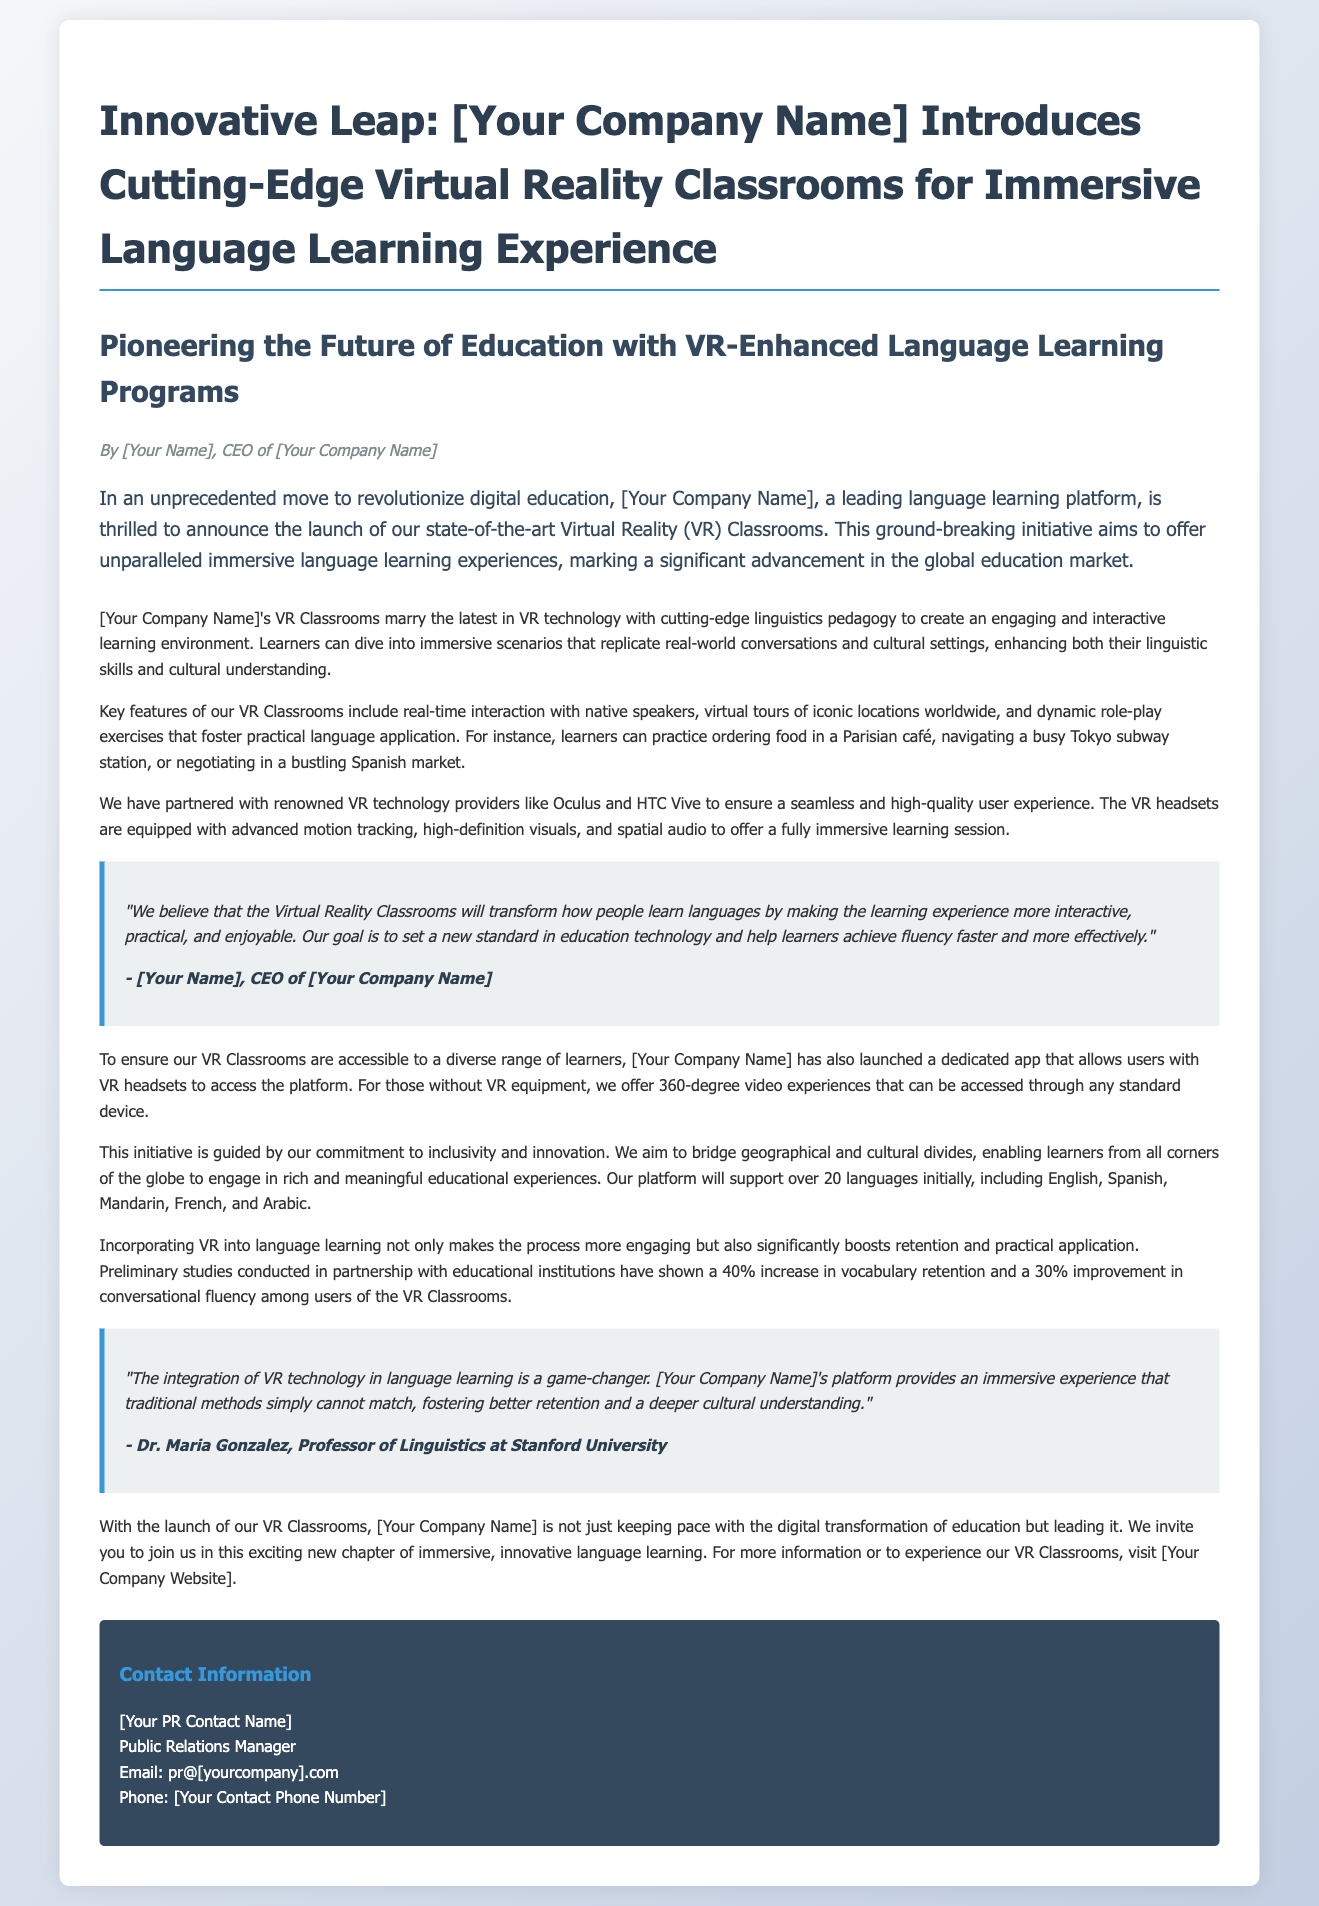What is the name of the company introducing VR Classrooms? The document states that the company is referred to as [Your Company Name], which indicates the placeholder for the actual company name.
Answer: [Your Company Name] What technology partners are mentioned for VR Classrooms? The document specifies that the company has partnered with Oculus and HTC Vive for the VR Classrooms initiative.
Answer: Oculus and HTC Vive How many languages will be supported initially? The document mentions that the platform will support over 20 languages at launch.
Answer: Over 20 languages What is the percentage increase in vocabulary retention noted in studies? According to the document, preliminary studies indicated a 40% increase in vocabulary retention for users of the VR Classrooms.
Answer: 40% Who is quoted in the document regarding the integration of VR technology? The document includes a quote from Dr. Maria Gonzalez regarding the impact of VR technology on language learning.
Answer: Dr. Maria Gonzalez What is one of the immersive experiences learners can practice in the VR Classrooms? The document provides an example experience where learners can practice ordering food in a Parisian café.
Answer: Ordering food in a Parisian café What is the objective of the launch of VR Classrooms according to the CEO? The document indicates that the goal is to set a new standard in education technology for language learning.
Answer: Set a new standard in education technology What email domain is used for public relations inquiries? The document provides the email format pr@[yourcompany].com for public relations contact.
Answer: pr@[yourcompany].com How does the company describe the immersive experience of the VR Classrooms? The document describes the VR Classrooms' experience as "interactive, practical, and enjoyable."
Answer: Interactive, practical, and enjoyable 